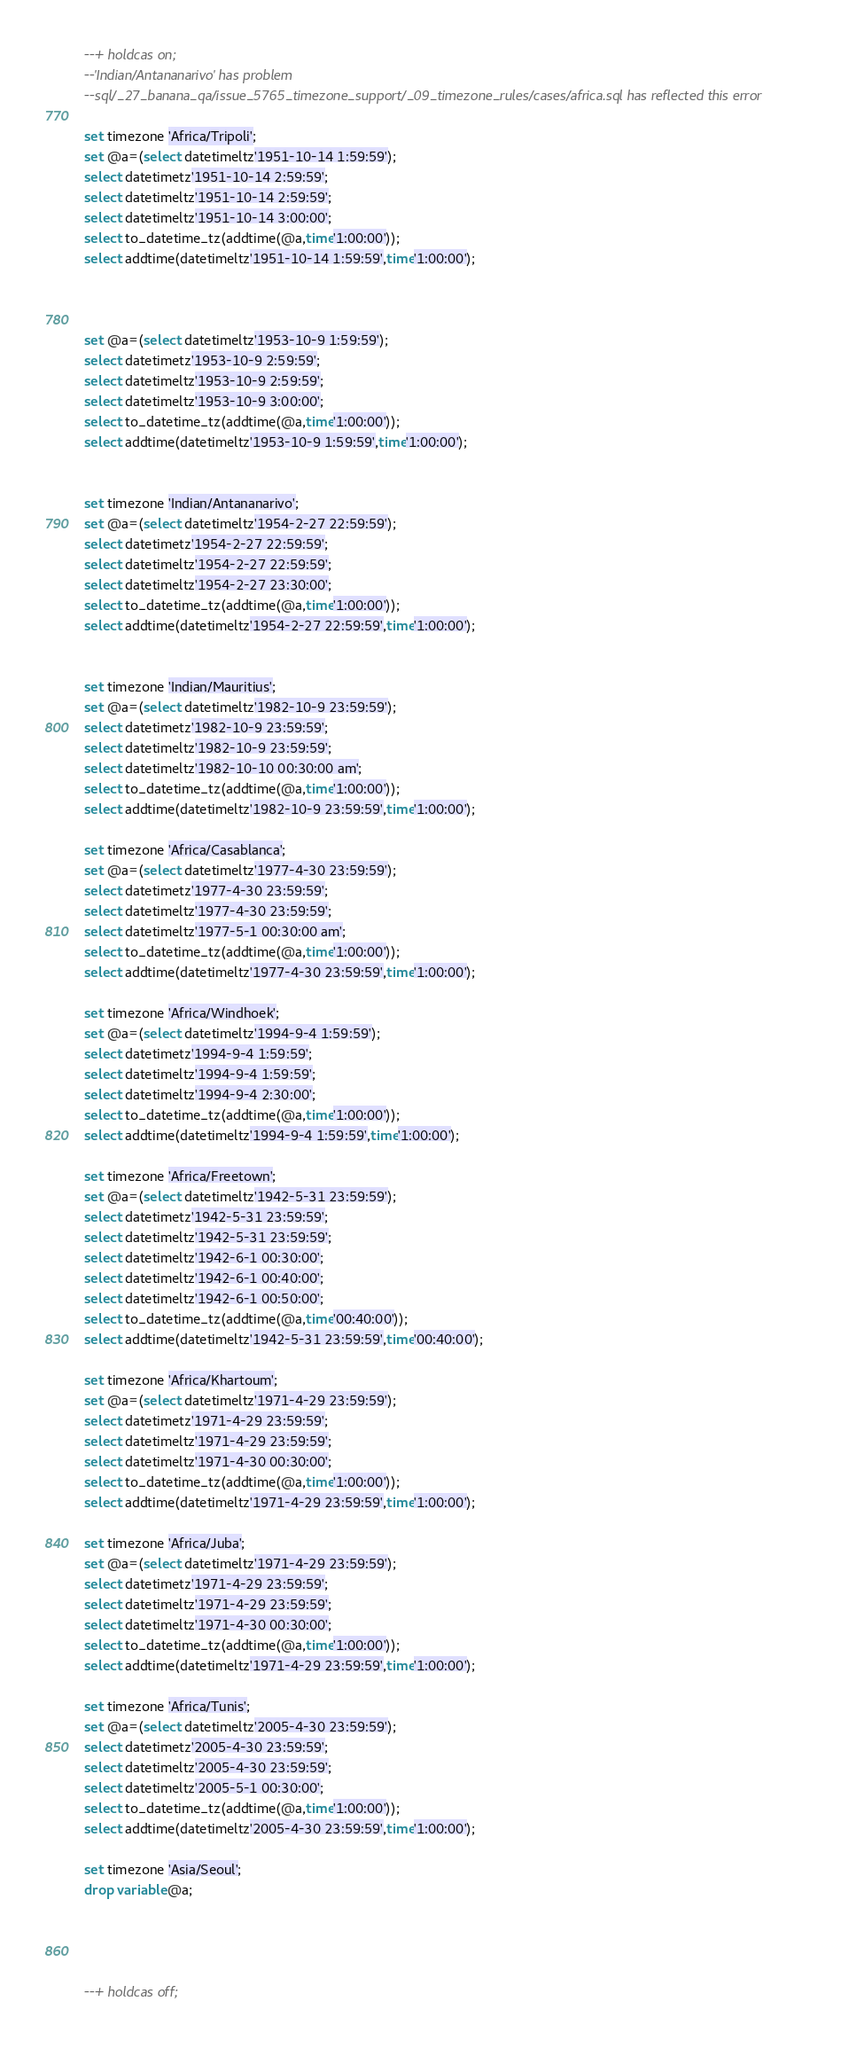<code> <loc_0><loc_0><loc_500><loc_500><_SQL_>--+ holdcas on;
--'Indian/Antananarivo' has problem
--sql/_27_banana_qa/issue_5765_timezone_support/_09_timezone_rules/cases/africa.sql has reflected this error 

set timezone 'Africa/Tripoli';
set @a=(select datetimeltz'1951-10-14 1:59:59');
select datetimetz'1951-10-14 2:59:59';
select datetimeltz'1951-10-14 2:59:59';
select datetimeltz'1951-10-14 3:00:00';
select to_datetime_tz(addtime(@a,time'1:00:00'));
select addtime(datetimeltz'1951-10-14 1:59:59',time'1:00:00');



set @a=(select datetimeltz'1953-10-9 1:59:59');
select datetimetz'1953-10-9 2:59:59';
select datetimeltz'1953-10-9 2:59:59';
select datetimeltz'1953-10-9 3:00:00';
select to_datetime_tz(addtime(@a,time'1:00:00'));
select addtime(datetimeltz'1953-10-9 1:59:59',time'1:00:00');


set timezone 'Indian/Antananarivo';
set @a=(select datetimeltz'1954-2-27 22:59:59');
select datetimetz'1954-2-27 22:59:59';
select datetimeltz'1954-2-27 22:59:59';
select datetimeltz'1954-2-27 23:30:00';
select to_datetime_tz(addtime(@a,time'1:00:00'));
select addtime(datetimeltz'1954-2-27 22:59:59',time'1:00:00');


set timezone 'Indian/Mauritius';
set @a=(select datetimeltz'1982-10-9 23:59:59');
select datetimetz'1982-10-9 23:59:59';
select datetimeltz'1982-10-9 23:59:59';
select datetimeltz'1982-10-10 00:30:00 am';
select to_datetime_tz(addtime(@a,time'1:00:00'));
select addtime(datetimeltz'1982-10-9 23:59:59',time'1:00:00');

set timezone 'Africa/Casablanca';
set @a=(select datetimeltz'1977-4-30 23:59:59');
select datetimetz'1977-4-30 23:59:59';
select datetimeltz'1977-4-30 23:59:59';
select datetimeltz'1977-5-1 00:30:00 am';
select to_datetime_tz(addtime(@a,time'1:00:00'));
select addtime(datetimeltz'1977-4-30 23:59:59',time'1:00:00');

set timezone 'Africa/Windhoek';
set @a=(select datetimeltz'1994-9-4 1:59:59');
select datetimetz'1994-9-4 1:59:59';
select datetimeltz'1994-9-4 1:59:59';
select datetimeltz'1994-9-4 2:30:00';
select to_datetime_tz(addtime(@a,time'1:00:00'));
select addtime(datetimeltz'1994-9-4 1:59:59',time'1:00:00');

set timezone 'Africa/Freetown';
set @a=(select datetimeltz'1942-5-31 23:59:59');
select datetimetz'1942-5-31 23:59:59';
select datetimeltz'1942-5-31 23:59:59';
select datetimeltz'1942-6-1 00:30:00';
select datetimeltz'1942-6-1 00:40:00';
select datetimeltz'1942-6-1 00:50:00';
select to_datetime_tz(addtime(@a,time'00:40:00'));
select addtime(datetimeltz'1942-5-31 23:59:59',time'00:40:00');

set timezone 'Africa/Khartoum';
set @a=(select datetimeltz'1971-4-29 23:59:59');
select datetimetz'1971-4-29 23:59:59';
select datetimeltz'1971-4-29 23:59:59';
select datetimeltz'1971-4-30 00:30:00';
select to_datetime_tz(addtime(@a,time'1:00:00'));
select addtime(datetimeltz'1971-4-29 23:59:59',time'1:00:00');

set timezone 'Africa/Juba';
set @a=(select datetimeltz'1971-4-29 23:59:59');
select datetimetz'1971-4-29 23:59:59';
select datetimeltz'1971-4-29 23:59:59';
select datetimeltz'1971-4-30 00:30:00';
select to_datetime_tz(addtime(@a,time'1:00:00'));
select addtime(datetimeltz'1971-4-29 23:59:59',time'1:00:00');

set timezone 'Africa/Tunis';
set @a=(select datetimeltz'2005-4-30 23:59:59');
select datetimetz'2005-4-30 23:59:59';
select datetimeltz'2005-4-30 23:59:59';
select datetimeltz'2005-5-1 00:30:00';
select to_datetime_tz(addtime(@a,time'1:00:00'));
select addtime(datetimeltz'2005-4-30 23:59:59',time'1:00:00');

set timezone 'Asia/Seoul';
drop variable @a;




--+ holdcas off;
</code> 